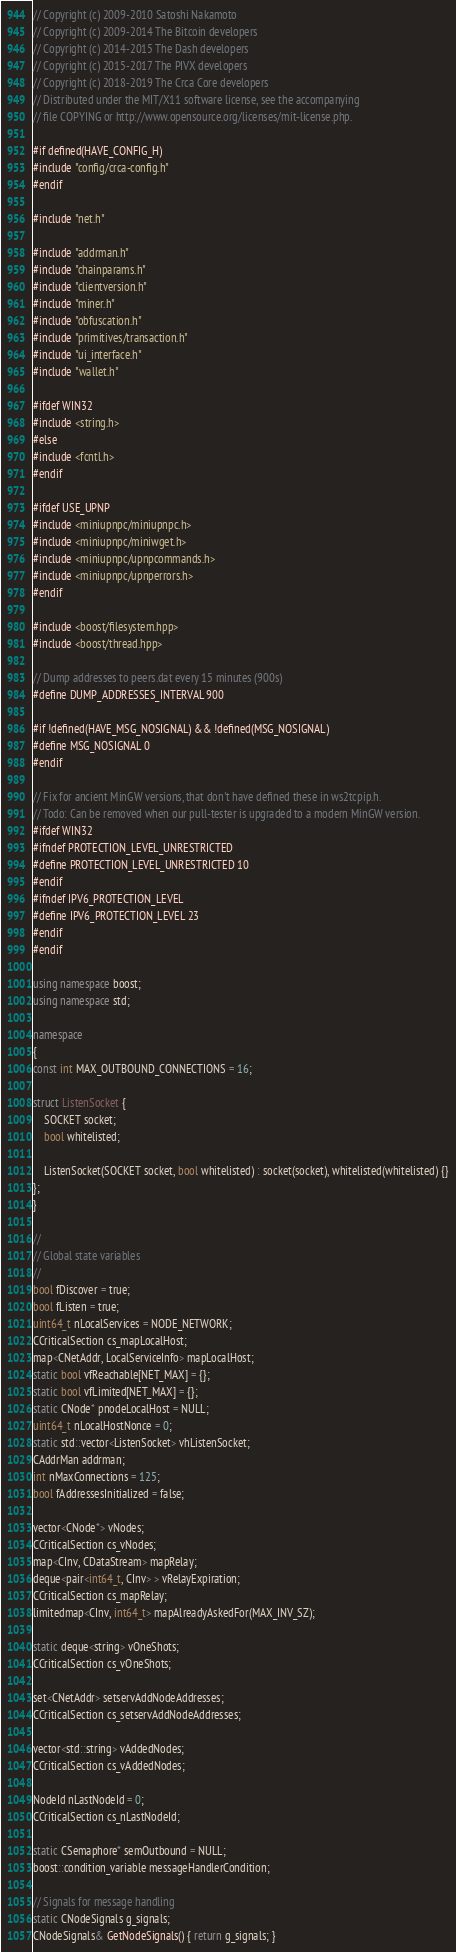<code> <loc_0><loc_0><loc_500><loc_500><_C++_>// Copyright (c) 2009-2010 Satoshi Nakamoto
// Copyright (c) 2009-2014 The Bitcoin developers
// Copyright (c) 2014-2015 The Dash developers
// Copyright (c) 2015-2017 The PIVX developers
// Copyright (c) 2018-2019 The Crca Core developers
// Distributed under the MIT/X11 software license, see the accompanying
// file COPYING or http://www.opensource.org/licenses/mit-license.php.

#if defined(HAVE_CONFIG_H)
#include "config/crca-config.h"
#endif

#include "net.h"

#include "addrman.h"
#include "chainparams.h"
#include "clientversion.h"
#include "miner.h"
#include "obfuscation.h"
#include "primitives/transaction.h"
#include "ui_interface.h"
#include "wallet.h"

#ifdef WIN32
#include <string.h>
#else
#include <fcntl.h>
#endif

#ifdef USE_UPNP
#include <miniupnpc/miniupnpc.h>
#include <miniupnpc/miniwget.h>
#include <miniupnpc/upnpcommands.h>
#include <miniupnpc/upnperrors.h>
#endif

#include <boost/filesystem.hpp>
#include <boost/thread.hpp>

// Dump addresses to peers.dat every 15 minutes (900s)
#define DUMP_ADDRESSES_INTERVAL 900

#if !defined(HAVE_MSG_NOSIGNAL) && !defined(MSG_NOSIGNAL)
#define MSG_NOSIGNAL 0
#endif

// Fix for ancient MinGW versions, that don't have defined these in ws2tcpip.h.
// Todo: Can be removed when our pull-tester is upgraded to a modern MinGW version.
#ifdef WIN32
#ifndef PROTECTION_LEVEL_UNRESTRICTED
#define PROTECTION_LEVEL_UNRESTRICTED 10
#endif
#ifndef IPV6_PROTECTION_LEVEL
#define IPV6_PROTECTION_LEVEL 23
#endif
#endif

using namespace boost;
using namespace std;

namespace
{
const int MAX_OUTBOUND_CONNECTIONS = 16;

struct ListenSocket {
    SOCKET socket;
    bool whitelisted;

    ListenSocket(SOCKET socket, bool whitelisted) : socket(socket), whitelisted(whitelisted) {}
};
}

//
// Global state variables
//
bool fDiscover = true;
bool fListen = true;
uint64_t nLocalServices = NODE_NETWORK;
CCriticalSection cs_mapLocalHost;
map<CNetAddr, LocalServiceInfo> mapLocalHost;
static bool vfReachable[NET_MAX] = {};
static bool vfLimited[NET_MAX] = {};
static CNode* pnodeLocalHost = NULL;
uint64_t nLocalHostNonce = 0;
static std::vector<ListenSocket> vhListenSocket;
CAddrMan addrman;
int nMaxConnections = 125;
bool fAddressesInitialized = false;

vector<CNode*> vNodes;
CCriticalSection cs_vNodes;
map<CInv, CDataStream> mapRelay;
deque<pair<int64_t, CInv> > vRelayExpiration;
CCriticalSection cs_mapRelay;
limitedmap<CInv, int64_t> mapAlreadyAskedFor(MAX_INV_SZ);

static deque<string> vOneShots;
CCriticalSection cs_vOneShots;

set<CNetAddr> setservAddNodeAddresses;
CCriticalSection cs_setservAddNodeAddresses;

vector<std::string> vAddedNodes;
CCriticalSection cs_vAddedNodes;

NodeId nLastNodeId = 0;
CCriticalSection cs_nLastNodeId;

static CSemaphore* semOutbound = NULL;
boost::condition_variable messageHandlerCondition;

// Signals for message handling
static CNodeSignals g_signals;
CNodeSignals& GetNodeSignals() { return g_signals; }
</code> 